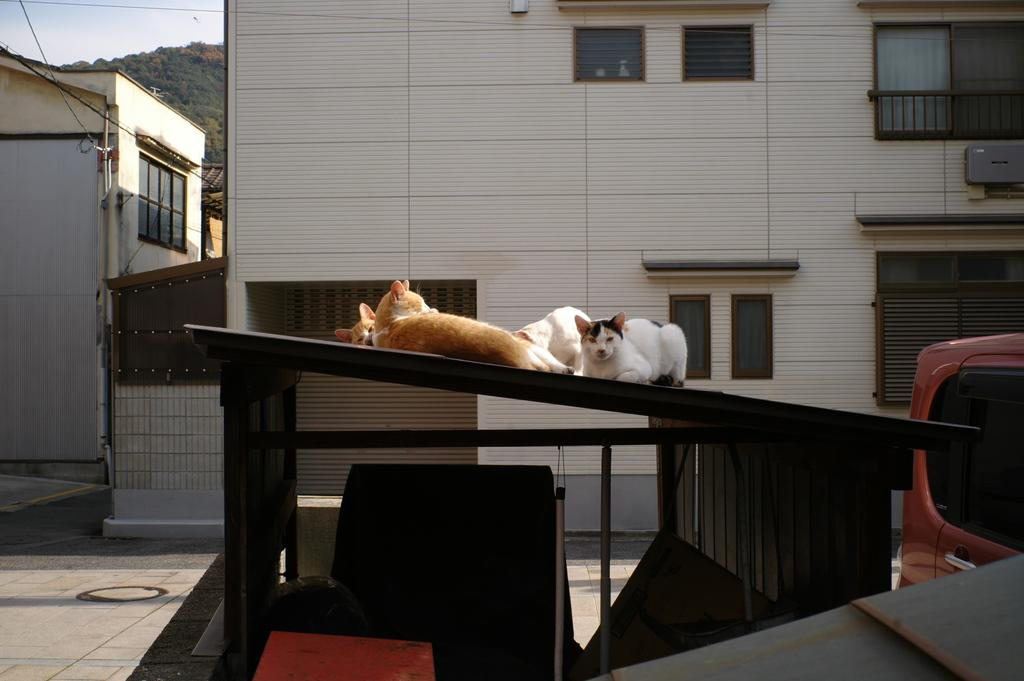What animals can be seen on the roof in the image? There are cats on the roof in the image. What type of structures can be seen in the background of the image? There are buildings in the background of the image. What type of vegetation is visible in the background of the image? There are trees in the background of the image. What else can be seen in the sky in the background of the image? The sky is visible in the background of the image. What else can be seen in the background of the image? There are wires and other objects on the ground in the background of the image. What note is the son playing on the roof in the image? There is no son or musical instrument present in the image; it features cats on the roof. What type of sponge is being used to clean the wires in the image? There is no sponge or cleaning activity depicted in the image; it only shows cats on the roof, buildings, trees, and wires in the background. 